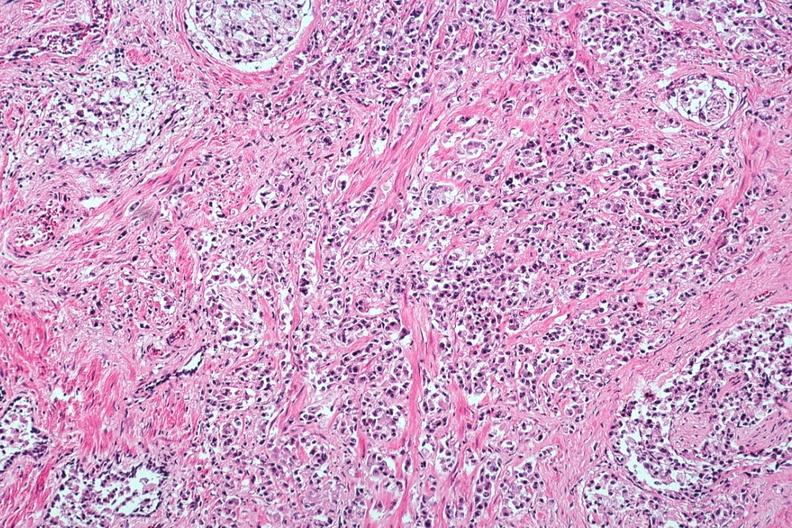what is present?
Answer the question using a single word or phrase. Prostate 